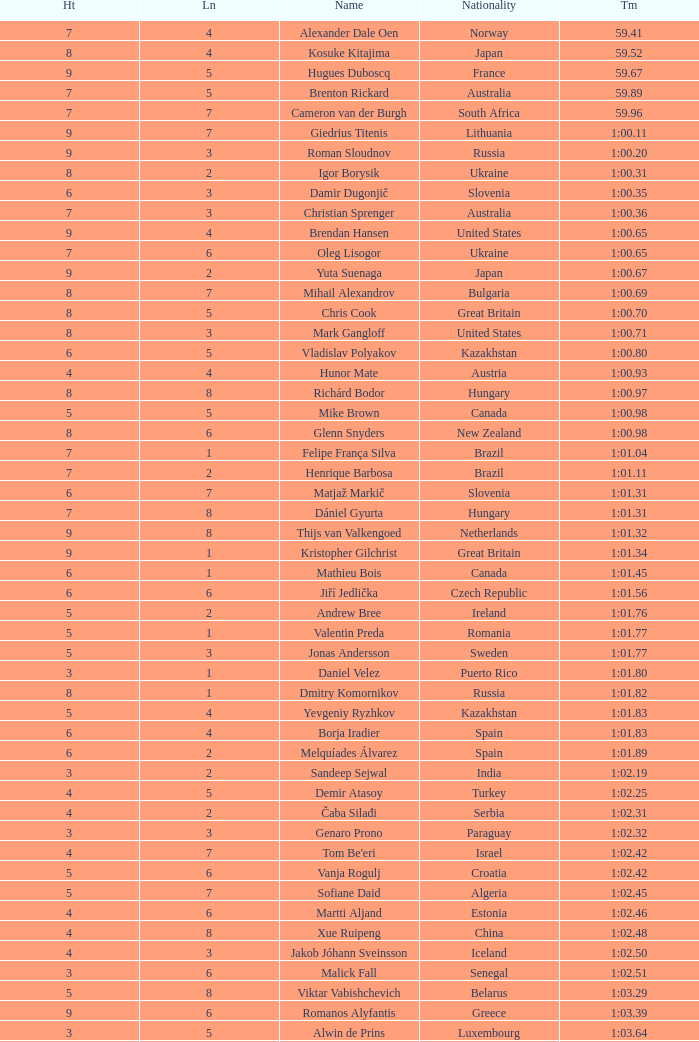What is the time in a heat smaller than 5, in Lane 5, for Vietnam? 1:06.36. 